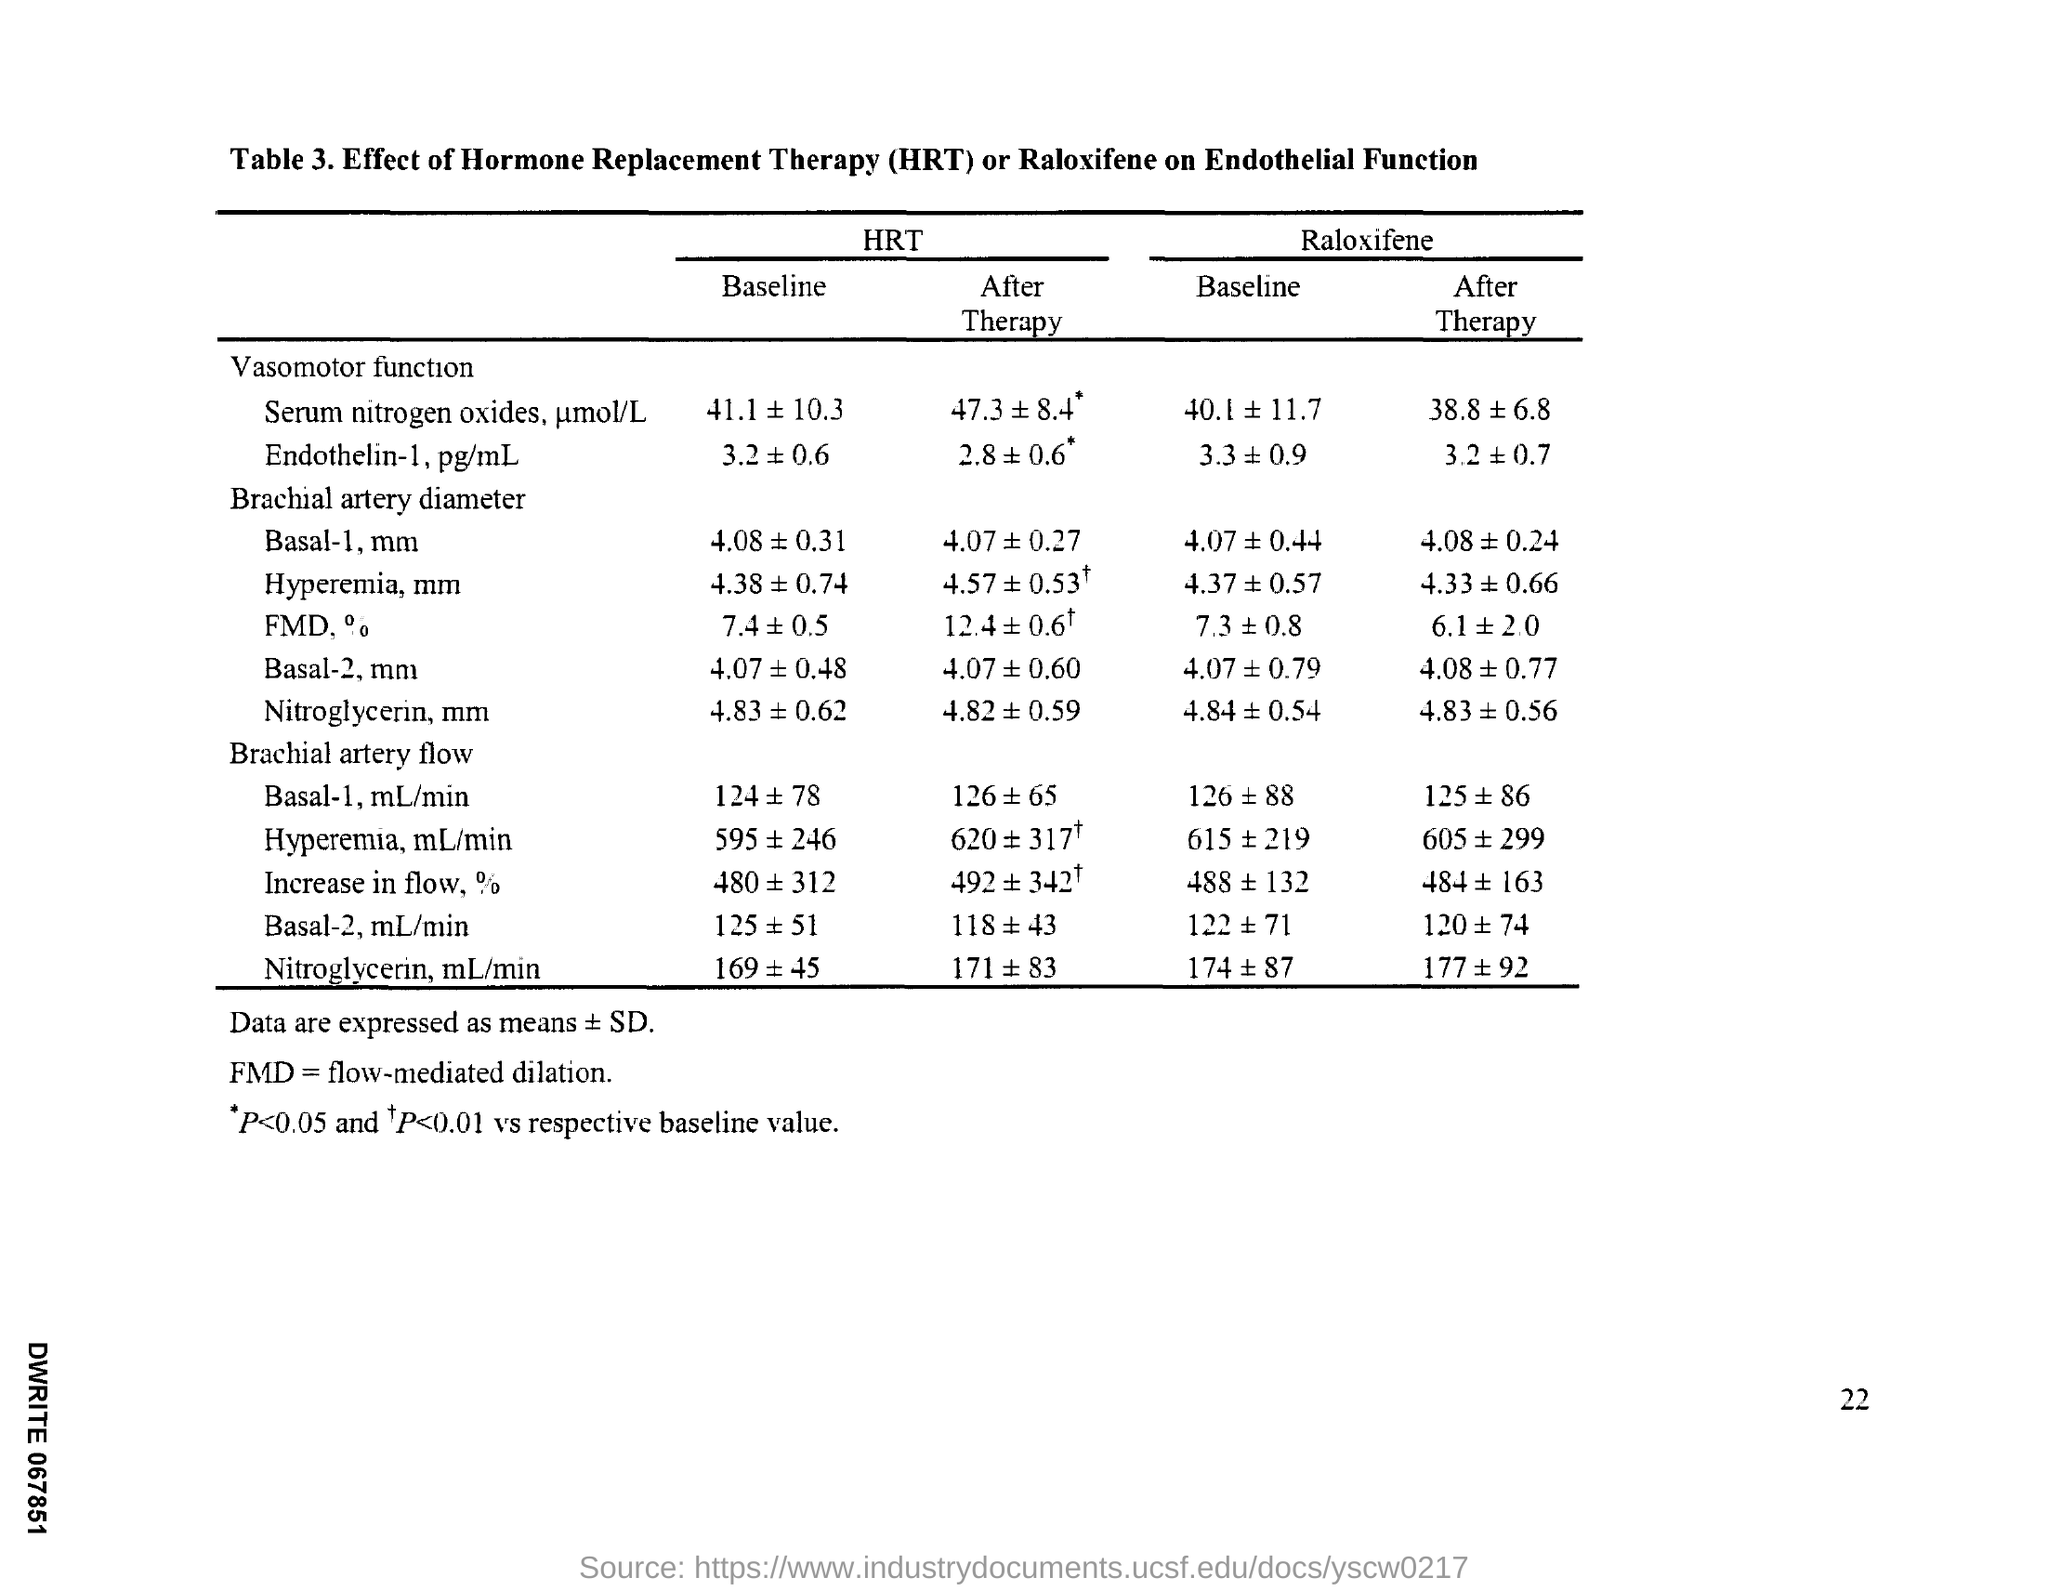What is the full form of fmd?
Ensure brevity in your answer.  Flow-mediated dilation. What is the full form of HRT?
Your response must be concise. Hormone replacement therapy. What is the Page Number?
Make the answer very short. 22. 